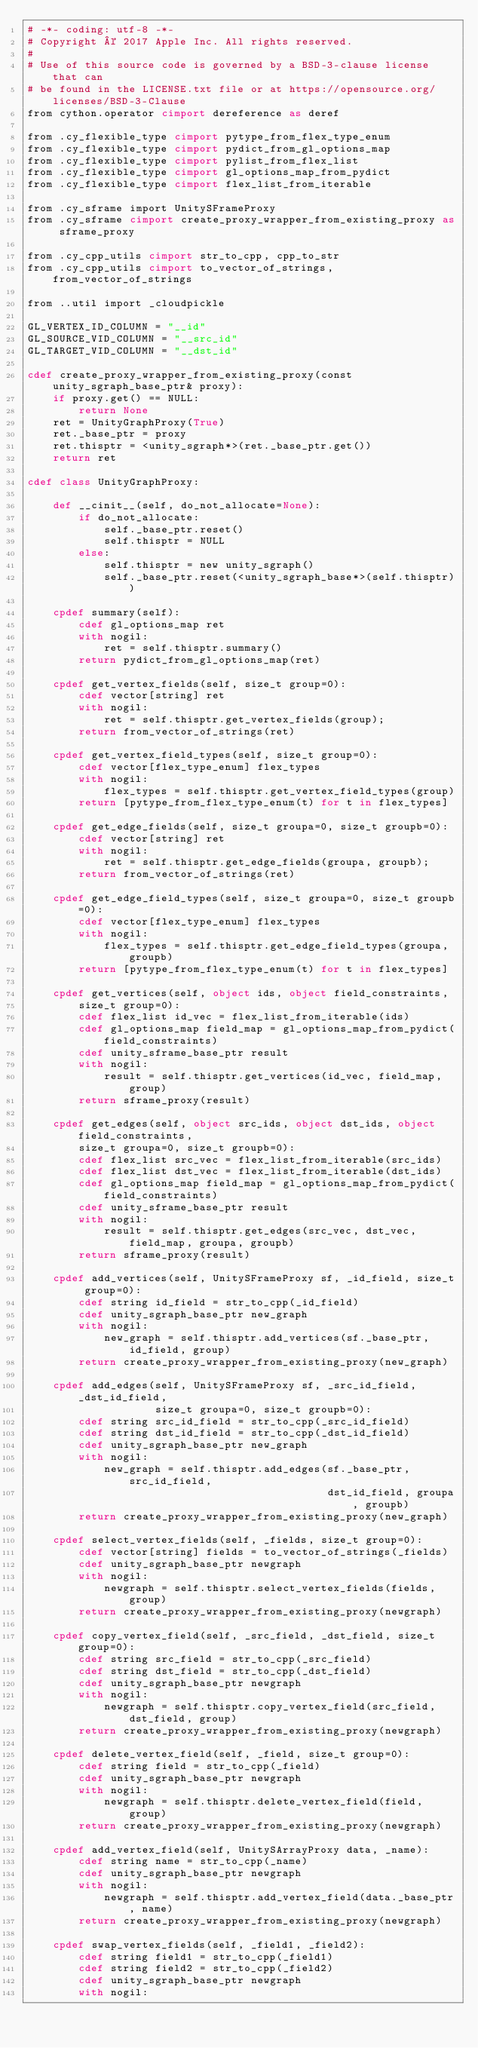Convert code to text. <code><loc_0><loc_0><loc_500><loc_500><_Cython_># -*- coding: utf-8 -*-
# Copyright © 2017 Apple Inc. All rights reserved.
#
# Use of this source code is governed by a BSD-3-clause license that can
# be found in the LICENSE.txt file or at https://opensource.org/licenses/BSD-3-Clause
from cython.operator cimport dereference as deref

from .cy_flexible_type cimport pytype_from_flex_type_enum
from .cy_flexible_type cimport pydict_from_gl_options_map
from .cy_flexible_type cimport pylist_from_flex_list
from .cy_flexible_type cimport gl_options_map_from_pydict
from .cy_flexible_type cimport flex_list_from_iterable

from .cy_sframe import UnitySFrameProxy
from .cy_sframe cimport create_proxy_wrapper_from_existing_proxy as sframe_proxy

from .cy_cpp_utils cimport str_to_cpp, cpp_to_str
from .cy_cpp_utils cimport to_vector_of_strings, from_vector_of_strings

from ..util import _cloudpickle

GL_VERTEX_ID_COLUMN = "__id" 
GL_SOURCE_VID_COLUMN = "__src_id" 
GL_TARGET_VID_COLUMN = "__dst_id" 

cdef create_proxy_wrapper_from_existing_proxy(const unity_sgraph_base_ptr& proxy):
    if proxy.get() == NULL:
        return None
    ret = UnityGraphProxy(True)
    ret._base_ptr = proxy
    ret.thisptr = <unity_sgraph*>(ret._base_ptr.get())
    return ret

cdef class UnityGraphProxy:

    def __cinit__(self, do_not_allocate=None):
        if do_not_allocate:
            self._base_ptr.reset()
            self.thisptr = NULL
        else:
            self.thisptr = new unity_sgraph()
            self._base_ptr.reset(<unity_sgraph_base*>(self.thisptr))

    cpdef summary(self):
        cdef gl_options_map ret 
        with nogil:
            ret = self.thisptr.summary()
        return pydict_from_gl_options_map(ret)

    cpdef get_vertex_fields(self, size_t group=0):
        cdef vector[string] ret
        with nogil:
            ret = self.thisptr.get_vertex_fields(group);
        return from_vector_of_strings(ret)

    cpdef get_vertex_field_types(self, size_t group=0):
        cdef vector[flex_type_enum] flex_types
        with nogil:
            flex_types = self.thisptr.get_vertex_field_types(group)
        return [pytype_from_flex_type_enum(t) for t in flex_types]

    cpdef get_edge_fields(self, size_t groupa=0, size_t groupb=0):
        cdef vector[string] ret
        with nogil:
            ret = self.thisptr.get_edge_fields(groupa, groupb);
        return from_vector_of_strings(ret)

    cpdef get_edge_field_types(self, size_t groupa=0, size_t groupb=0):
        cdef vector[flex_type_enum] flex_types
        with nogil:
            flex_types = self.thisptr.get_edge_field_types(groupa, groupb)
        return [pytype_from_flex_type_enum(t) for t in flex_types]

    cpdef get_vertices(self, object ids, object field_constraints,
        size_t group=0):
        cdef flex_list id_vec = flex_list_from_iterable(ids)
        cdef gl_options_map field_map = gl_options_map_from_pydict(field_constraints)
        cdef unity_sframe_base_ptr result 
        with nogil:
            result = self.thisptr.get_vertices(id_vec, field_map, group)
        return sframe_proxy(result)

    cpdef get_edges(self, object src_ids, object dst_ids, object field_constraints,
        size_t groupa=0, size_t groupb=0):
        cdef flex_list src_vec = flex_list_from_iterable(src_ids)
        cdef flex_list dst_vec = flex_list_from_iterable(dst_ids)
        cdef gl_options_map field_map = gl_options_map_from_pydict(field_constraints)
        cdef unity_sframe_base_ptr result 
        with nogil:
            result = self.thisptr.get_edges(src_vec, dst_vec, field_map, groupa, groupb)
        return sframe_proxy(result)

    cpdef add_vertices(self, UnitySFrameProxy sf, _id_field, size_t group=0):
        cdef string id_field = str_to_cpp(_id_field)
        cdef unity_sgraph_base_ptr new_graph 
        with nogil:
            new_graph = self.thisptr.add_vertices(sf._base_ptr, id_field, group)
        return create_proxy_wrapper_from_existing_proxy(new_graph)

    cpdef add_edges(self, UnitySFrameProxy sf, _src_id_field, _dst_id_field,
                    size_t groupa=0, size_t groupb=0):
        cdef string src_id_field = str_to_cpp(_src_id_field)
        cdef string dst_id_field = str_to_cpp(_dst_id_field)
        cdef unity_sgraph_base_ptr new_graph 
        with nogil:
            new_graph = self.thisptr.add_edges(sf._base_ptr, src_id_field, 
                                               dst_id_field, groupa, groupb)
        return create_proxy_wrapper_from_existing_proxy(new_graph)

    cpdef select_vertex_fields(self, _fields, size_t group=0):
        cdef vector[string] fields = to_vector_of_strings(_fields)
        cdef unity_sgraph_base_ptr newgraph 
        with nogil:
            newgraph = self.thisptr.select_vertex_fields(fields, group)
        return create_proxy_wrapper_from_existing_proxy(newgraph)

    cpdef copy_vertex_field(self, _src_field, _dst_field, size_t group=0):
        cdef string src_field = str_to_cpp(_src_field)
        cdef string dst_field = str_to_cpp(_dst_field)
        cdef unity_sgraph_base_ptr newgraph 
        with nogil:
            newgraph = self.thisptr.copy_vertex_field(src_field, dst_field, group)
        return create_proxy_wrapper_from_existing_proxy(newgraph)

    cpdef delete_vertex_field(self, _field, size_t group=0):
        cdef string field = str_to_cpp(_field)
        cdef unity_sgraph_base_ptr newgraph 
        with nogil:
            newgraph = self.thisptr.delete_vertex_field(field, group)
        return create_proxy_wrapper_from_existing_proxy(newgraph)

    cpdef add_vertex_field(self, UnitySArrayProxy data, _name):
        cdef string name = str_to_cpp(_name)
        cdef unity_sgraph_base_ptr newgraph 
        with nogil:
            newgraph = self.thisptr.add_vertex_field(data._base_ptr, name)
        return create_proxy_wrapper_from_existing_proxy(newgraph)

    cpdef swap_vertex_fields(self, _field1, _field2):
        cdef string field1 = str_to_cpp(_field1)
        cdef string field2 = str_to_cpp(_field2)
        cdef unity_sgraph_base_ptr newgraph 
        with nogil:</code> 